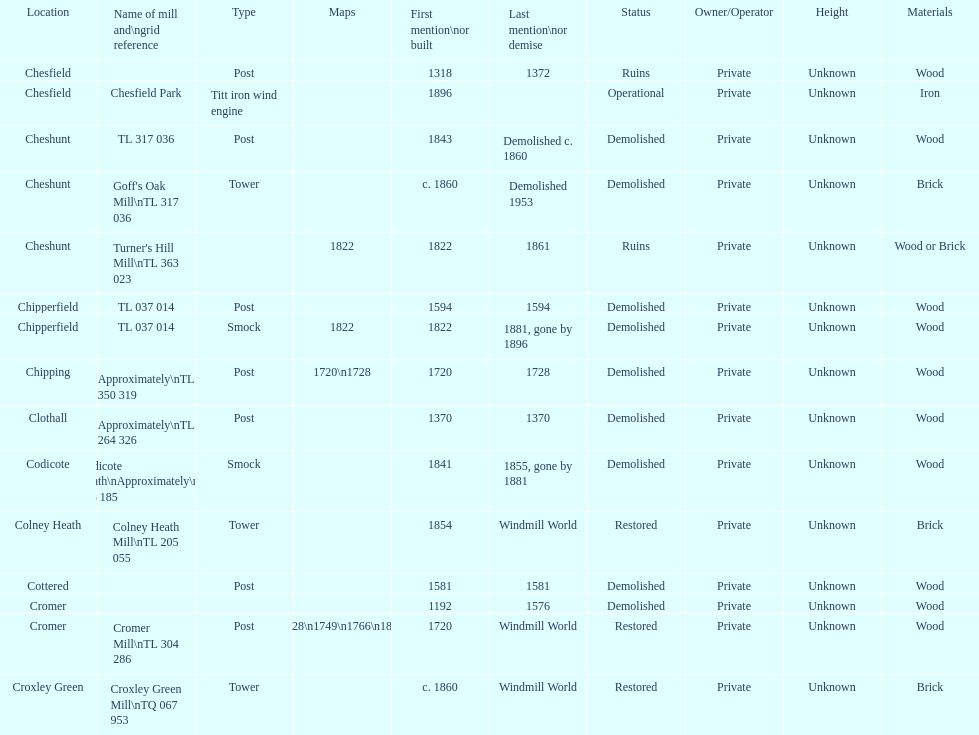Did cromer, chipperfield or cheshunt have the most windmills? Cheshunt. 